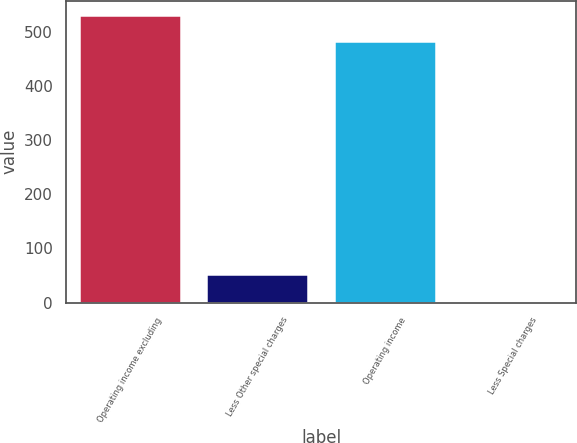Convert chart. <chart><loc_0><loc_0><loc_500><loc_500><bar_chart><fcel>Operating income excluding<fcel>Less Other special charges<fcel>Operating income<fcel>Less Special charges<nl><fcel>530.31<fcel>52.41<fcel>481.6<fcel>3.7<nl></chart> 